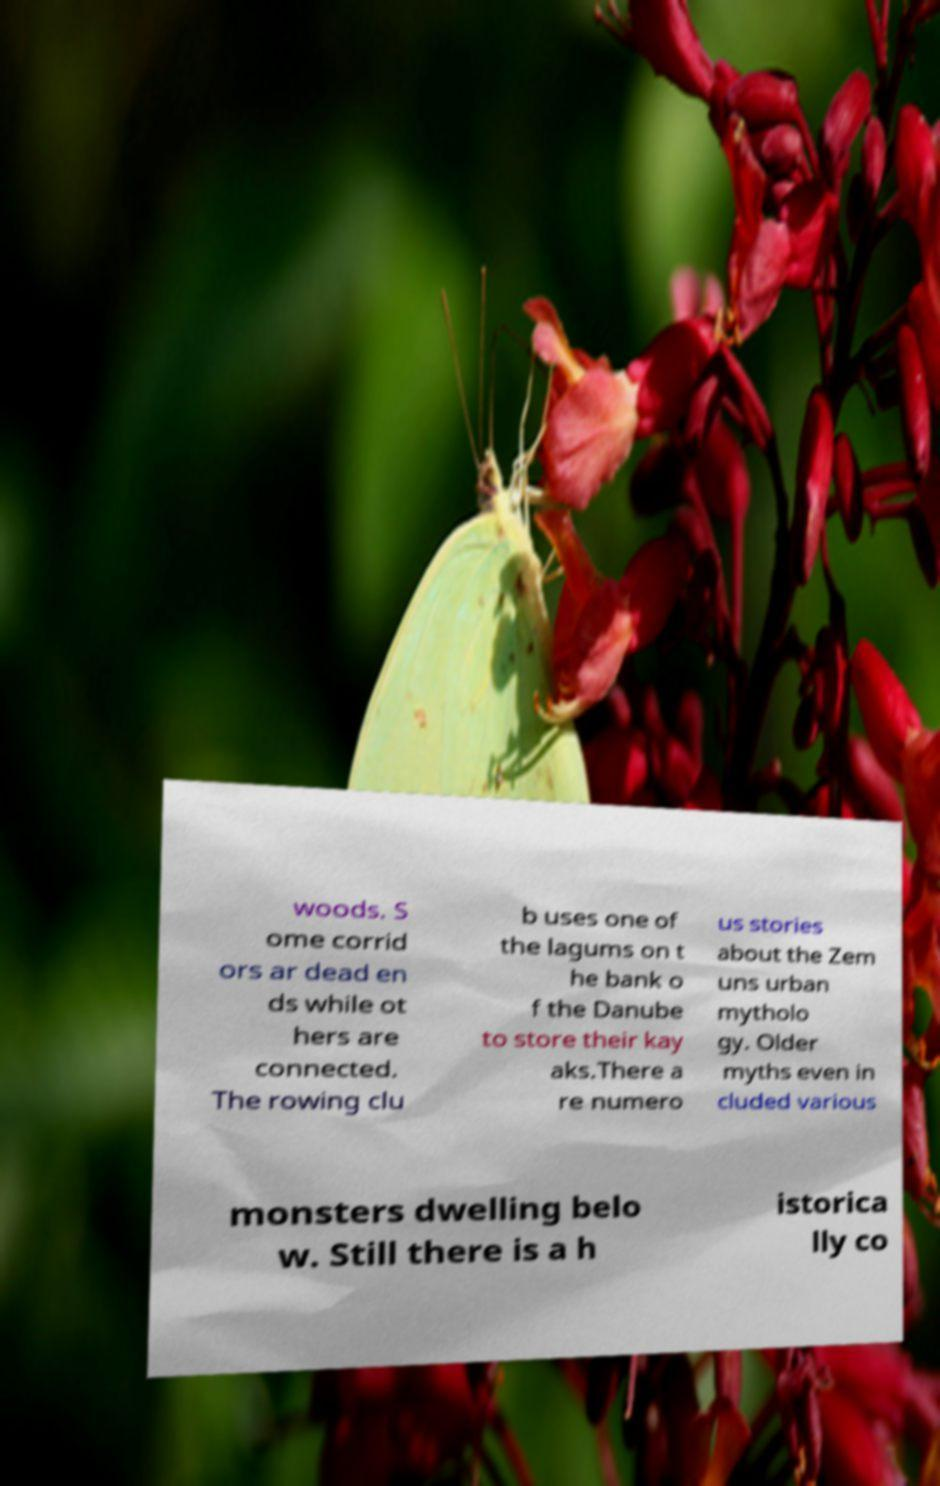I need the written content from this picture converted into text. Can you do that? woods. S ome corrid ors ar dead en ds while ot hers are connected. The rowing clu b uses one of the lagums on t he bank o f the Danube to store their kay aks.There a re numero us stories about the Zem uns urban mytholo gy. Older myths even in cluded various monsters dwelling belo w. Still there is a h istorica lly co 